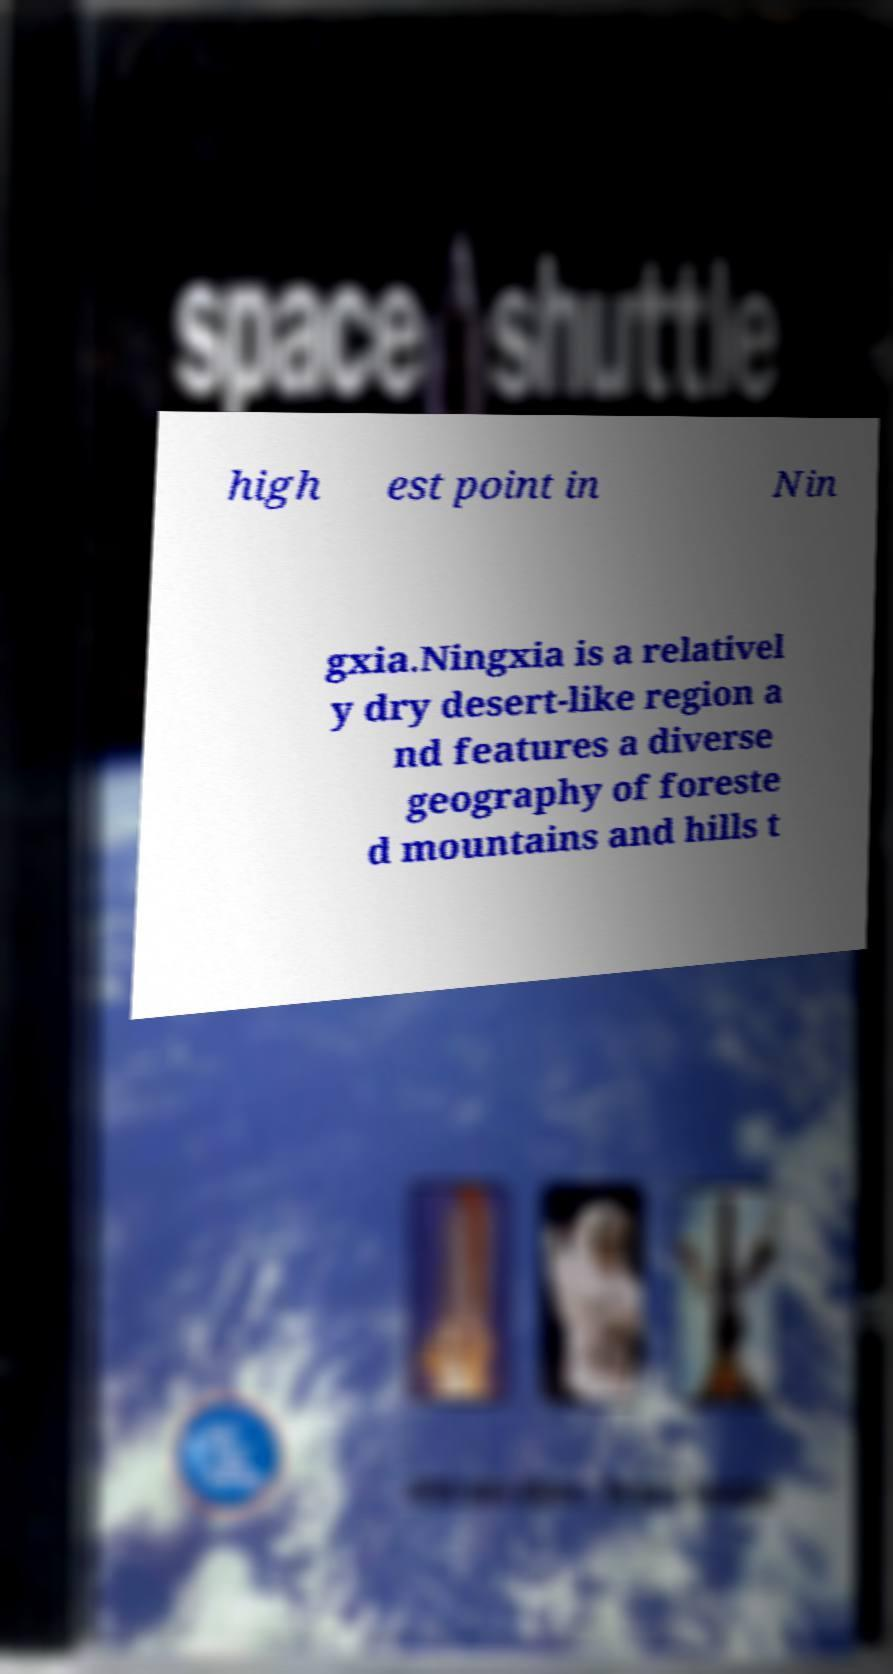Can you read and provide the text displayed in the image?This photo seems to have some interesting text. Can you extract and type it out for me? high est point in Nin gxia.Ningxia is a relativel y dry desert-like region a nd features a diverse geography of foreste d mountains and hills t 